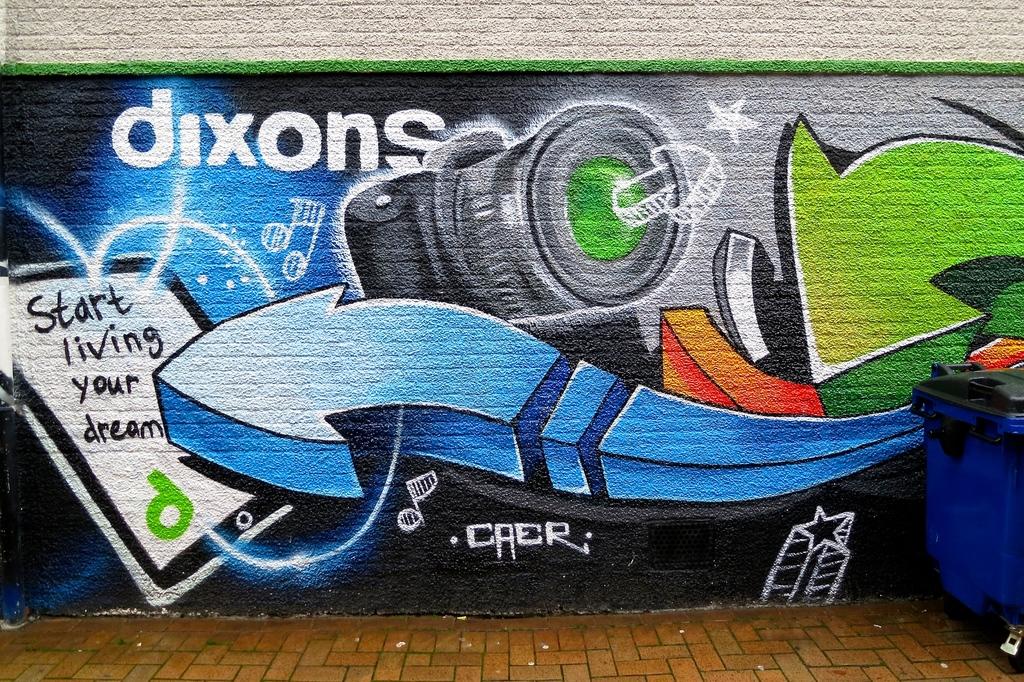What should you start living?
Your answer should be compact. Your dream. 